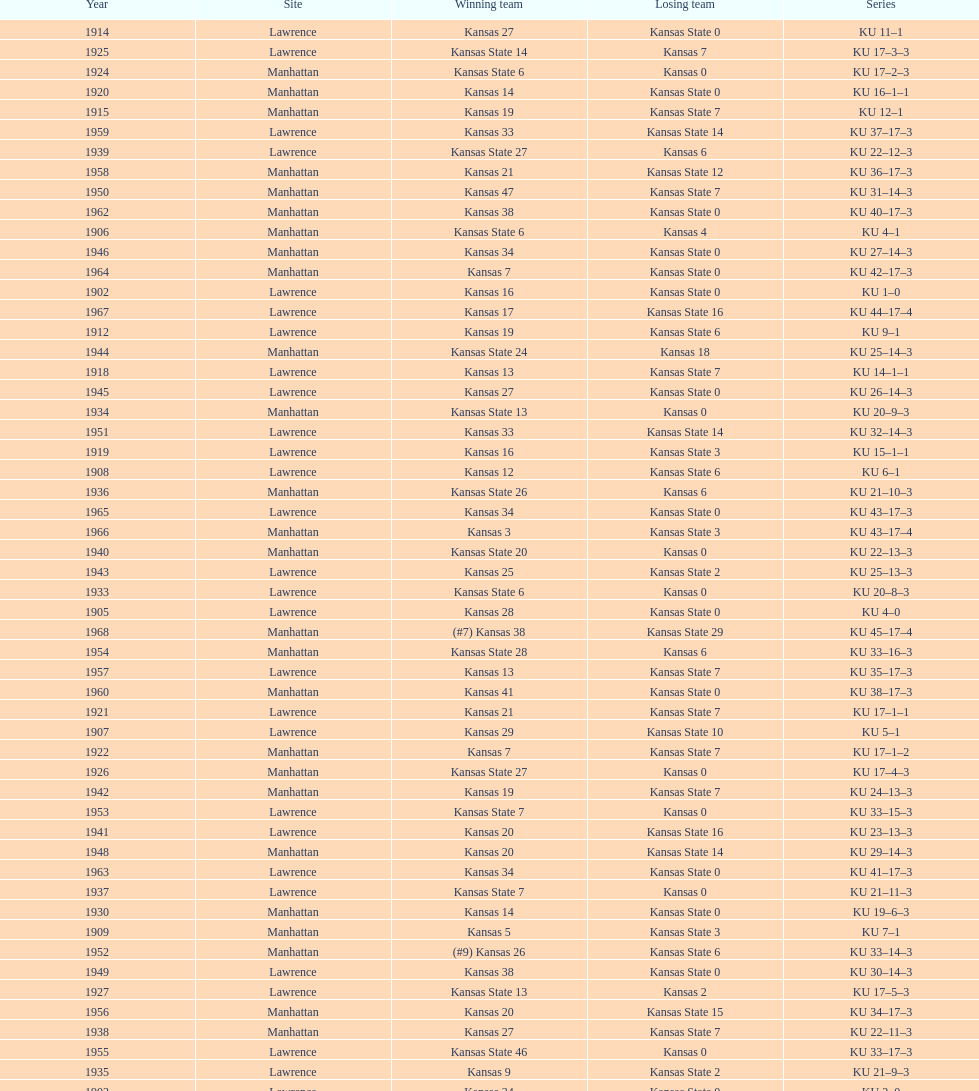How many times did kansas state not score at all against kansas from 1902-1968? 23. 